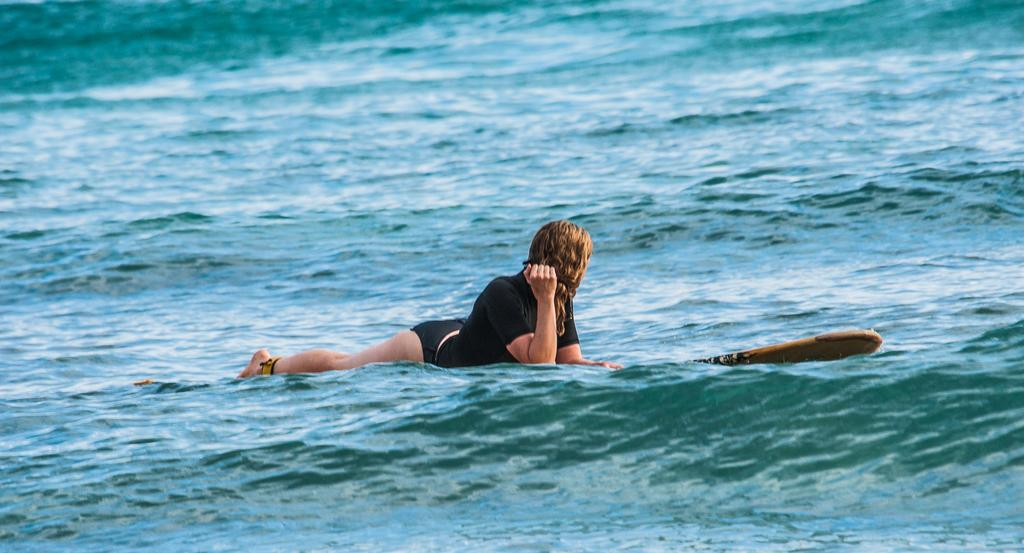Who is the main subject in the image? There is a woman in the image. What is the woman doing in the image? The woman is surfing on the water. How is the woman positioned while surfing? The woman is lying on a surfboard. What type of environment is visible in the image? There is water visible in the image. What type of bomb can be seen in the image? There is no bomb present in the image; it features a woman surfing on the water. How does the pest affect the woman's surfing experience in the image? There is no pest mentioned or visible in the image, so it cannot affect the woman's surfing experience. 